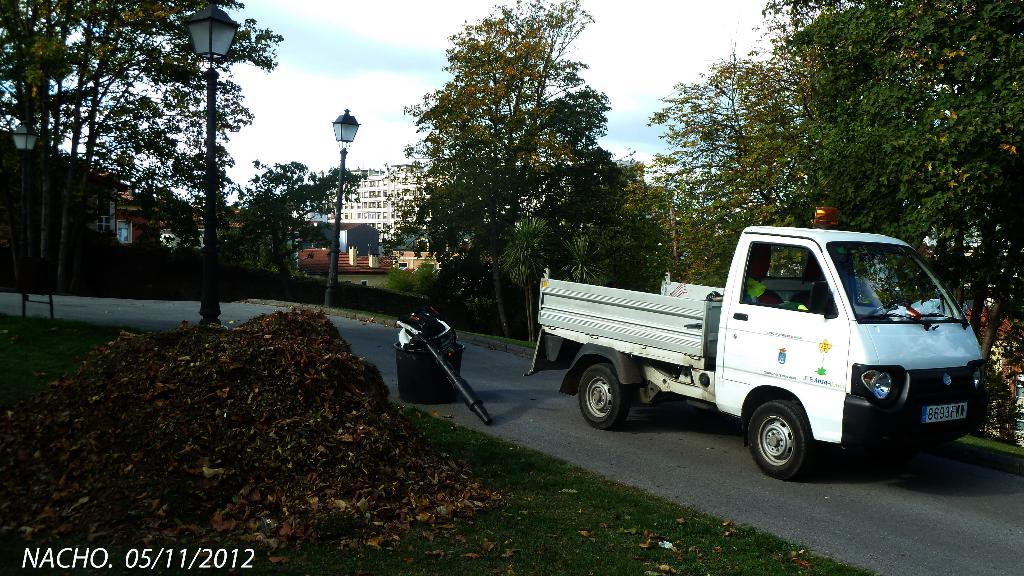What is located on the right side of the image? There is a vehicle on the right side of the image. Where is the vehicle situated? The vehicle is on the road. What can be seen on the left side of the image? There are many dry leaves on the left side of the image. What is in the middle of the image? There are trees, a street light, and buildings in the middle of the image. What is visible in the sky? The sky is visible in the middle of the image, and clouds are present. What type of thought can be seen in the image? There are no thoughts present in the image; it is a scene featuring a vehicle, dry leaves, trees, a street light, buildings, and clouds. Is there a doll visible in the image? No, there is no doll present in the image. 